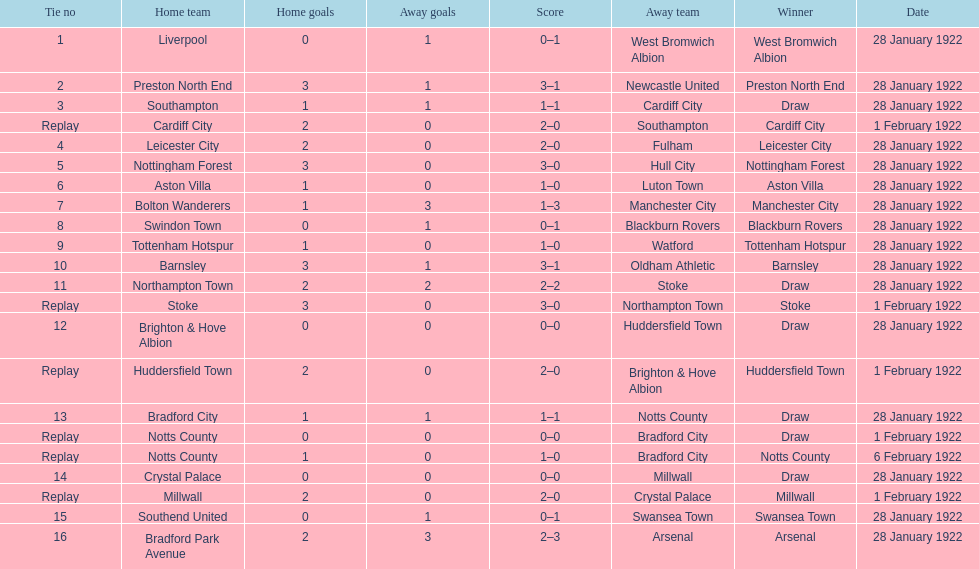How many games had no points scored? 3. 